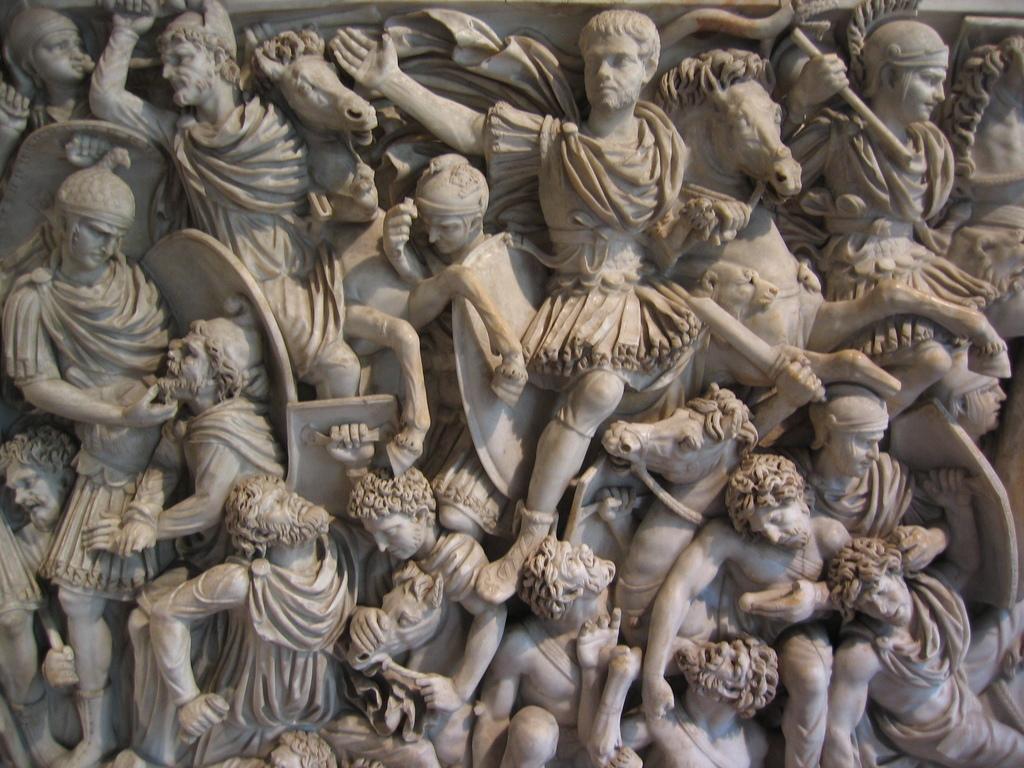In one or two sentences, can you explain what this image depicts? In this picture I can see sculpture of few men and horses. 